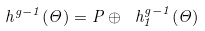<formula> <loc_0><loc_0><loc_500><loc_500>\ h ^ { g - 1 } ( \Theta ) = P \oplus \ h ^ { g - 1 } _ { 1 } ( \Theta )</formula> 